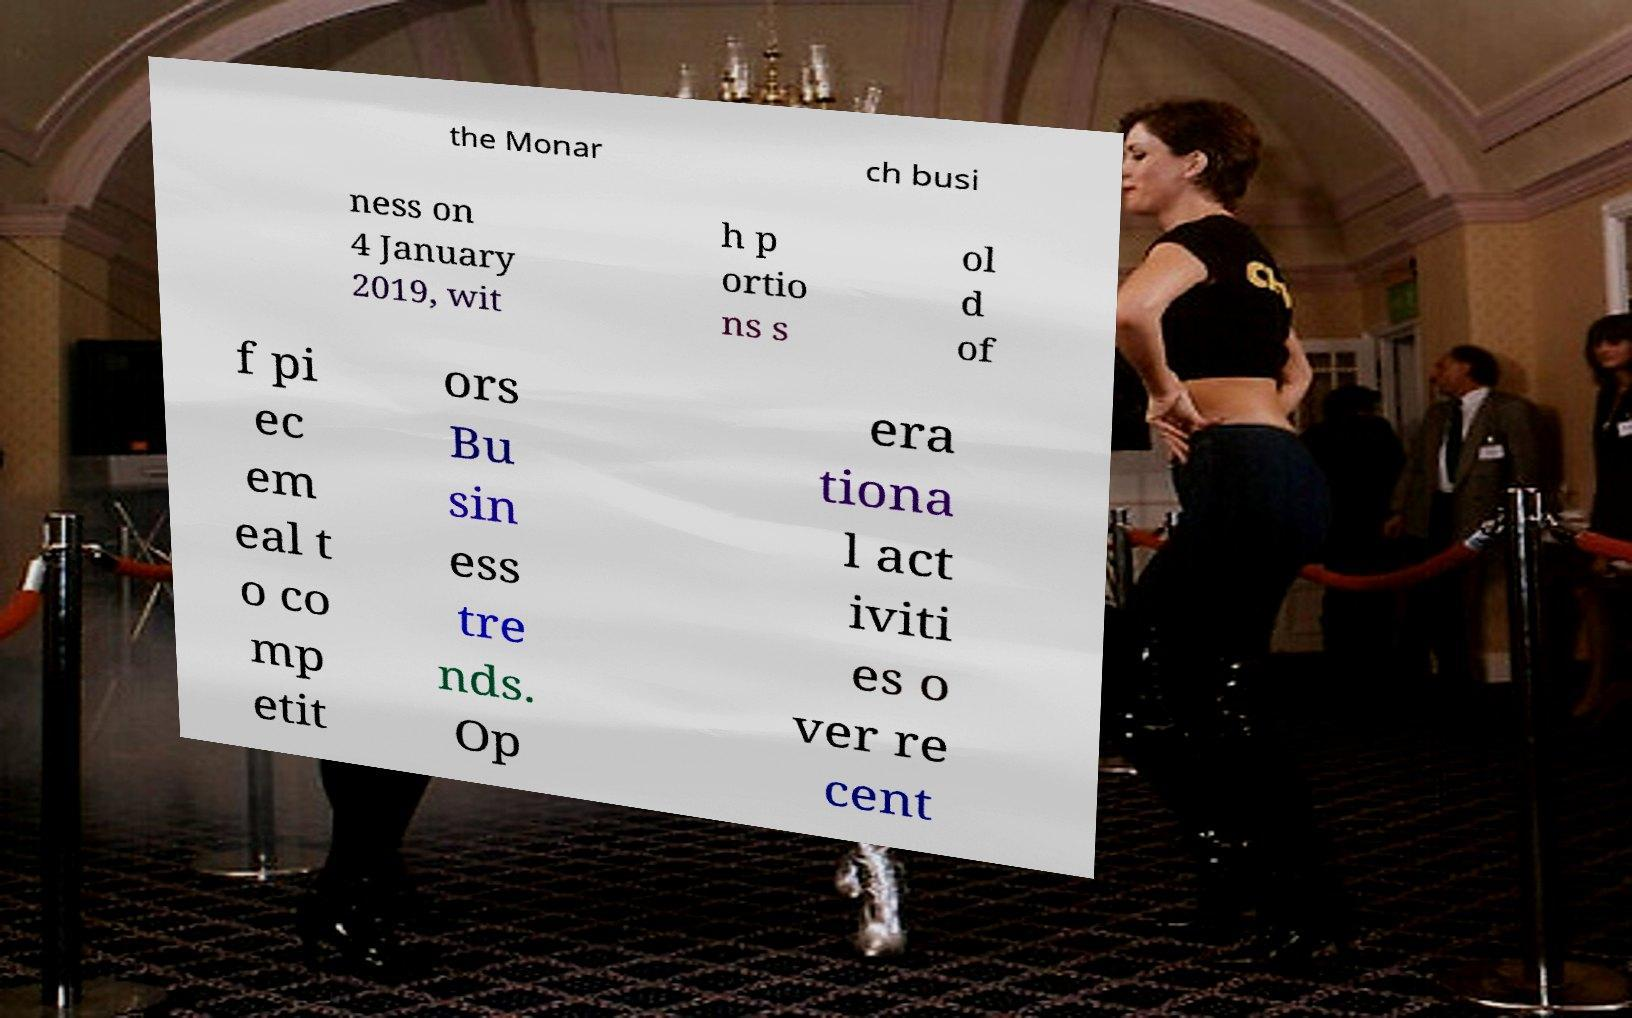There's text embedded in this image that I need extracted. Can you transcribe it verbatim? the Monar ch busi ness on 4 January 2019, wit h p ortio ns s ol d of f pi ec em eal t o co mp etit ors Bu sin ess tre nds. Op era tiona l act iviti es o ver re cent 